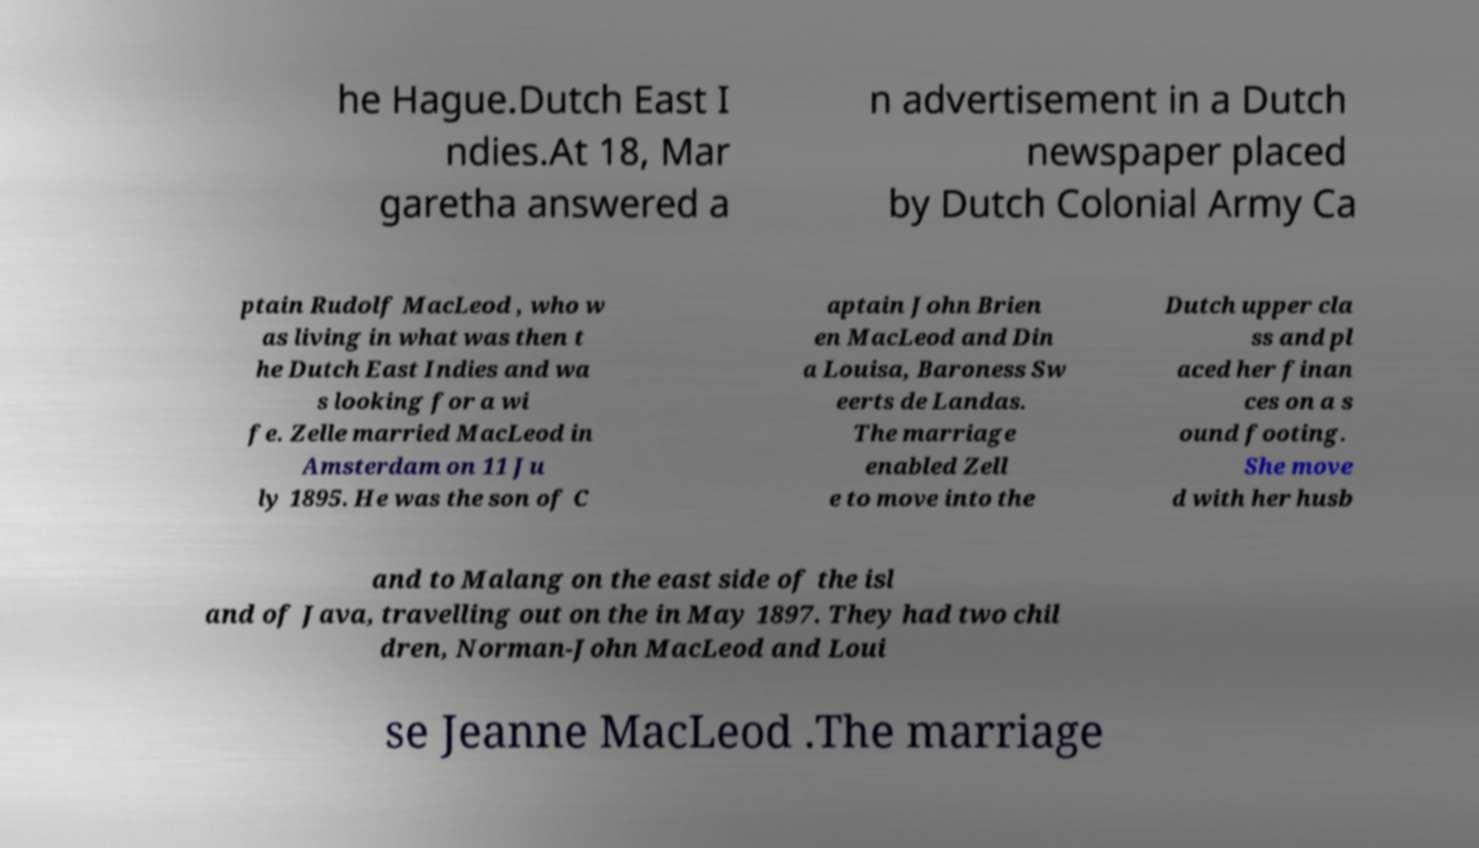What messages or text are displayed in this image? I need them in a readable, typed format. he Hague.Dutch East I ndies.At 18, Mar garetha answered a n advertisement in a Dutch newspaper placed by Dutch Colonial Army Ca ptain Rudolf MacLeod , who w as living in what was then t he Dutch East Indies and wa s looking for a wi fe. Zelle married MacLeod in Amsterdam on 11 Ju ly 1895. He was the son of C aptain John Brien en MacLeod and Din a Louisa, Baroness Sw eerts de Landas. The marriage enabled Zell e to move into the Dutch upper cla ss and pl aced her finan ces on a s ound footing. She move d with her husb and to Malang on the east side of the isl and of Java, travelling out on the in May 1897. They had two chil dren, Norman-John MacLeod and Loui se Jeanne MacLeod .The marriage 